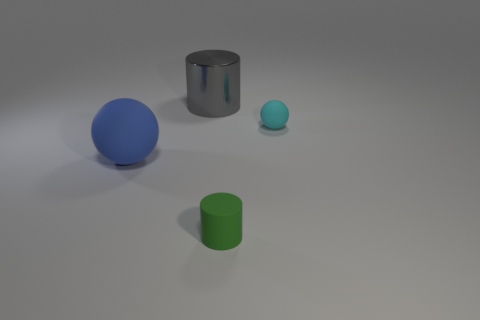What color is the rubber ball to the left of the small thing on the left side of the ball that is on the right side of the blue matte sphere?
Make the answer very short. Blue. There is a object in front of the large rubber object; what is its color?
Provide a short and direct response. Green. There is a rubber ball that is the same size as the metallic cylinder; what color is it?
Make the answer very short. Blue. Do the cyan ball and the matte cylinder have the same size?
Provide a short and direct response. Yes. There is a tiny sphere; how many tiny cyan things are on the right side of it?
Make the answer very short. 0. What number of things are things that are left of the small green object or green rubber objects?
Your answer should be compact. 3. Are there more tiny things behind the big metal cylinder than matte cylinders that are left of the small green matte thing?
Offer a terse response. No. There is a blue thing; is it the same size as the ball that is to the right of the blue object?
Your answer should be very brief. No. How many cubes are either tiny gray objects or green matte objects?
Your answer should be compact. 0. There is a cyan ball that is the same material as the green cylinder; what size is it?
Ensure brevity in your answer.  Small. 